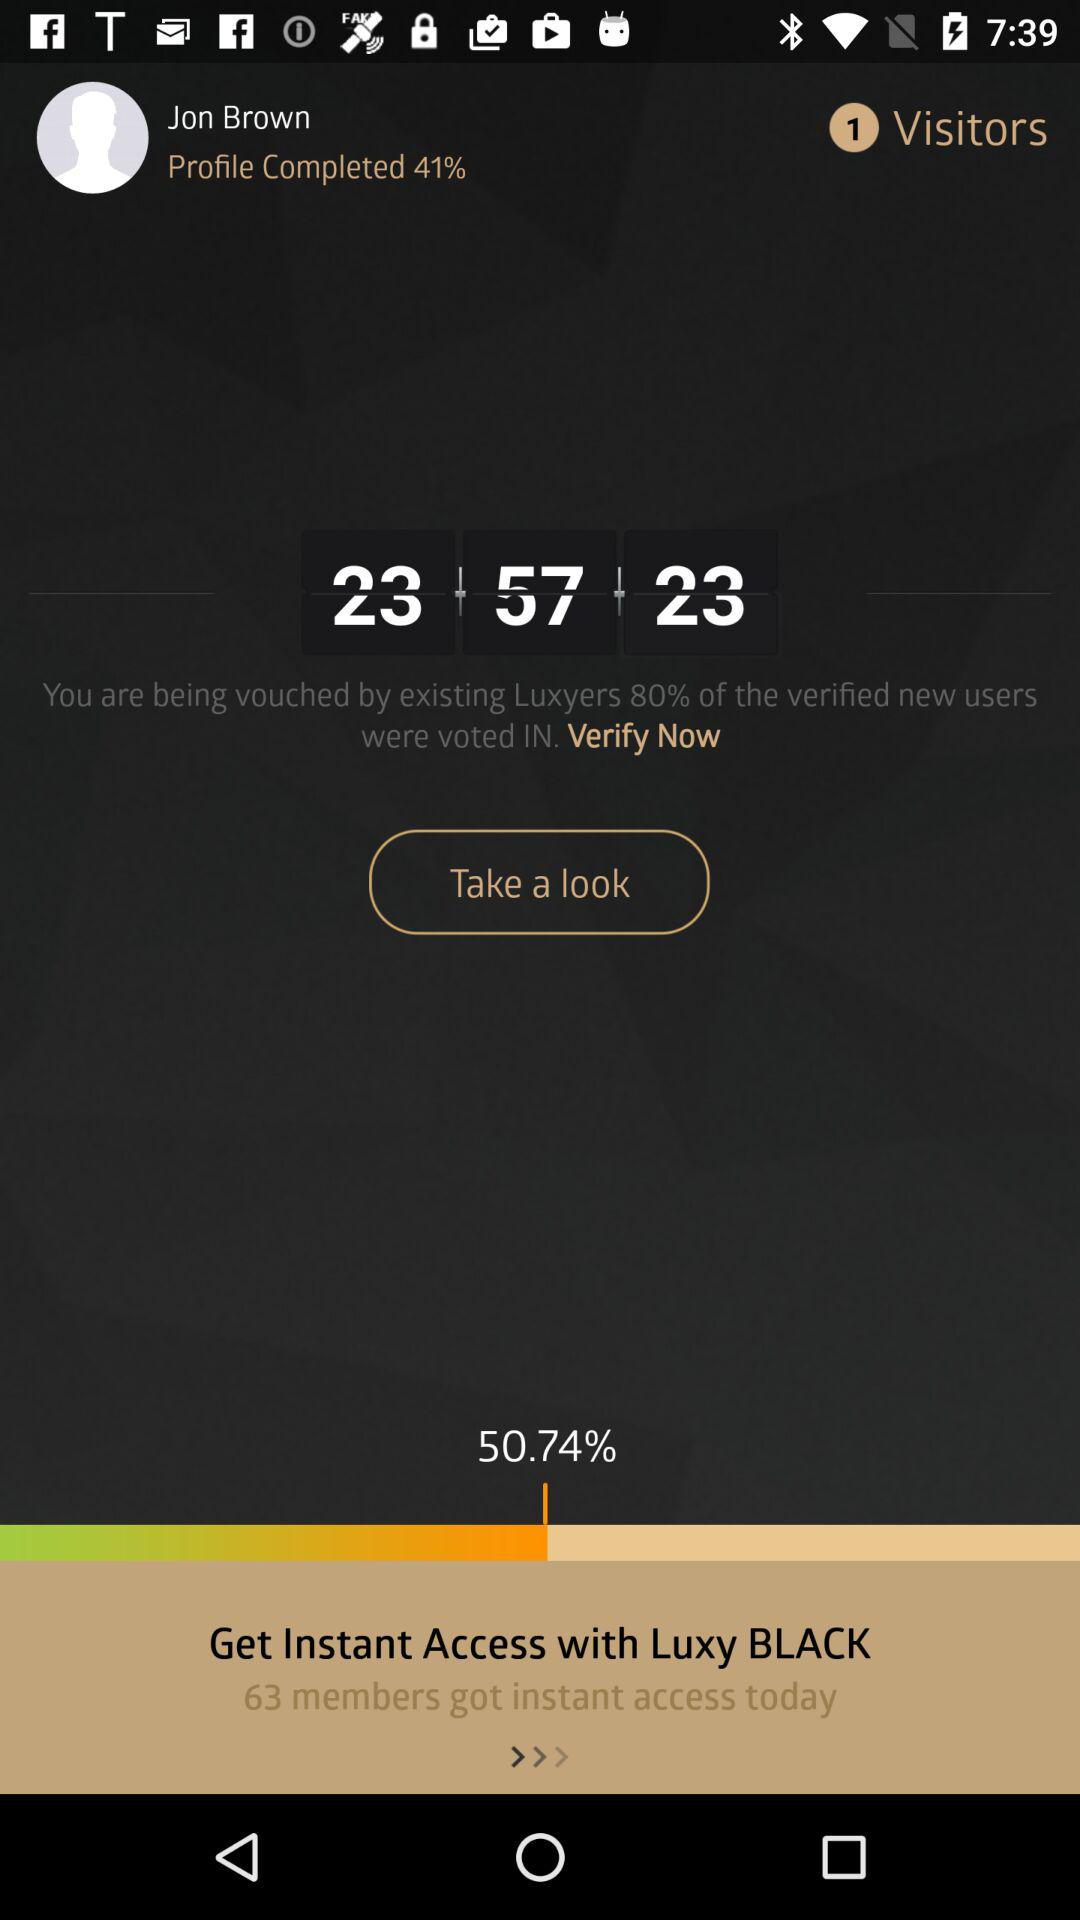What is the percentage of verified new users? The percentage of verified new users is 80. 